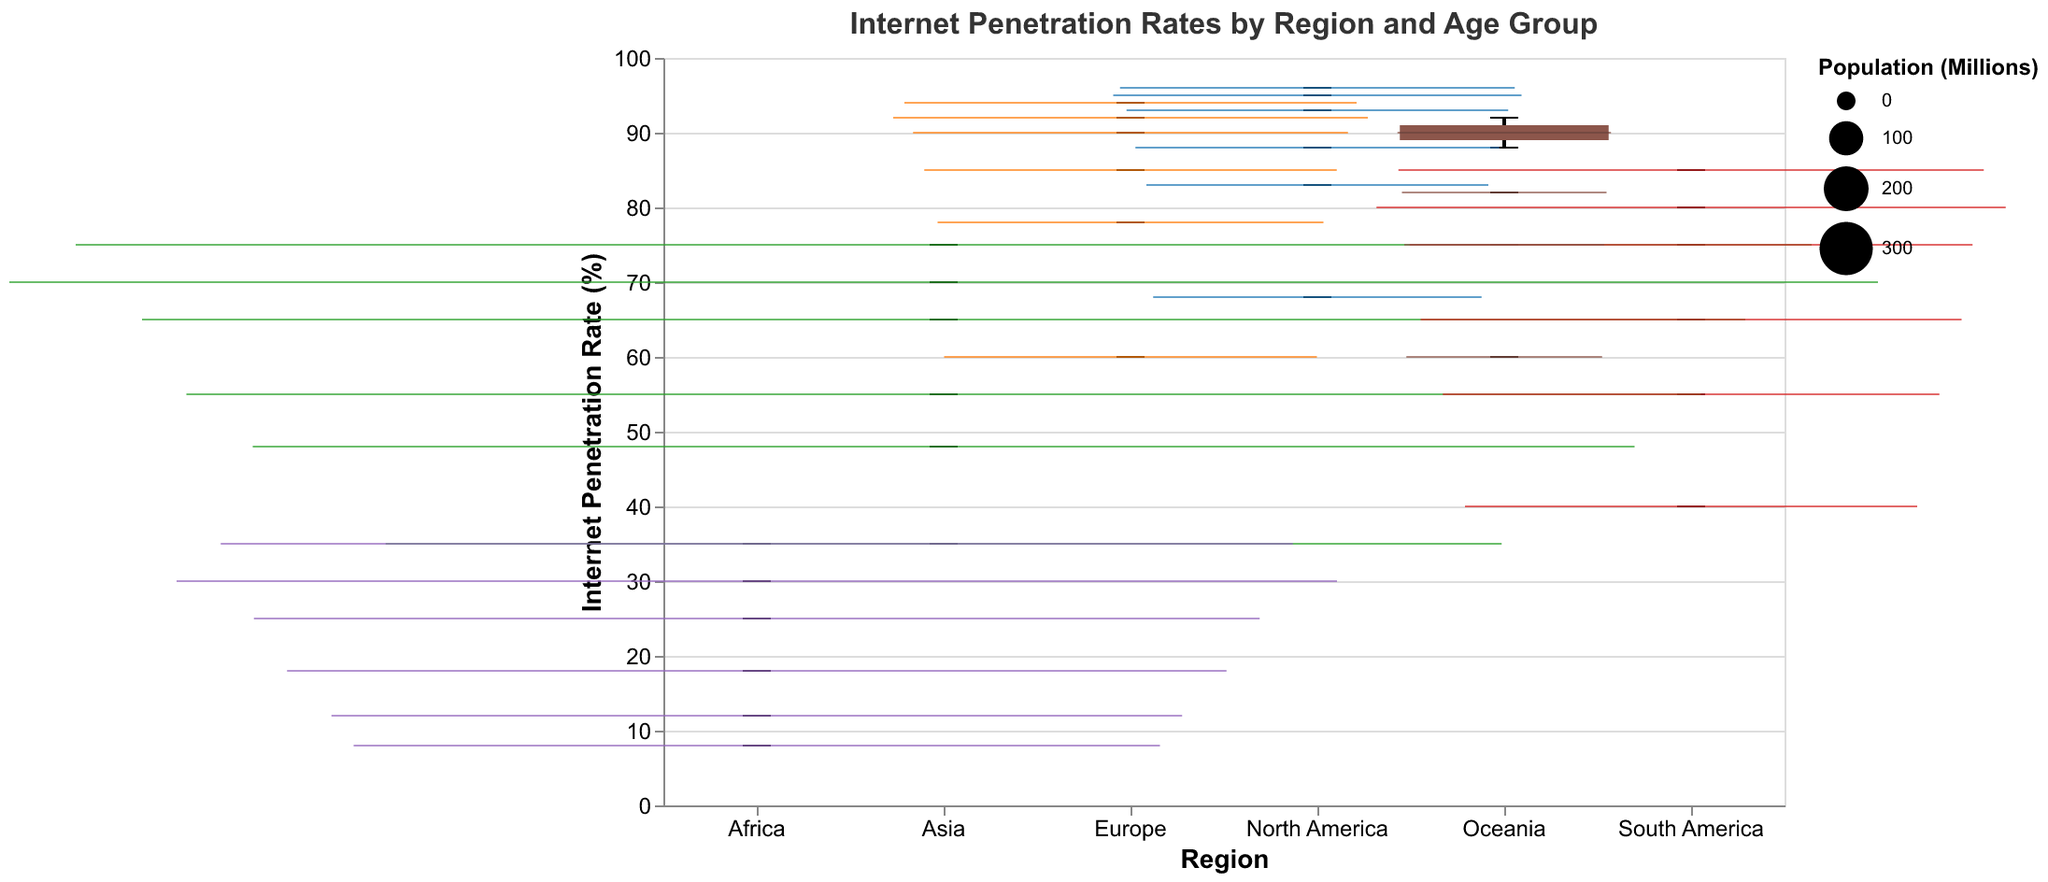What is the median internet penetration rate for North America? The box plot for North America shows the median line inside the box. From the plot, the median internet penetration rate can be visually determined.
Answer: 90.5 Which region has the highest internet penetration rate for the 65+ age group? By examining the end points of the box plot whiskers, we can identify which region has the highest value for the 65+ age group. North America shows the highest value.
Answer: North America How does the median internet penetration rate for Europe compare with that of South America? To compare the median rates, we must check the median lines within the box plots for both Europe and South America. Europe’s median is higher than South America's.
Answer: Europe’s median is higher What is the difference in internet penetration rates between the youngest and oldest age groups in Asia? For Asia, subtract the internet penetration rate of the oldest age group (65+) from that of the youngest age group (18-24).
Answer: 40 In which region is the range of internet penetration rates (the difference between the minimum and maximum values) the narrowest? By evaluating the overall range (distance between the whiskers) for each region's box plot, we can determine which has the narrowest range. This appears to be Europe.
Answer: Europe Which region shows the largest variance in internet penetration rates across all age groups? The region with the widest overall spread between the minimum and maximum whiskers indicates the greatest variance. This is Africa.
Answer: Africa What is the average internet penetration rate for North America across all age groups? Sum the internet penetration rates for North America and then divide by the number of age groups. Calculation: (96+95+93+88+83+68)/6 = 86.167
Answer: 86.17 In terms of internet access, which demographic is better connected, the 18-24 age group in South America or the 25-34 age group in Asia? By directly comparing the internet penetration rates for these groups (85% for South America 18-24 and 70% for Asia 25-34), we see that South America's 18-24 group is better connected.
Answer: South America 18-24 What is the median internet penetration rate for Oceania, and how does it compare to North America? Locate the median line in Oceania’s box plot and compare it to North America’s median line. Oceania's median is approximately 80, which is lower than North America's 90.5.
Answer: Oceania’s median is lower 